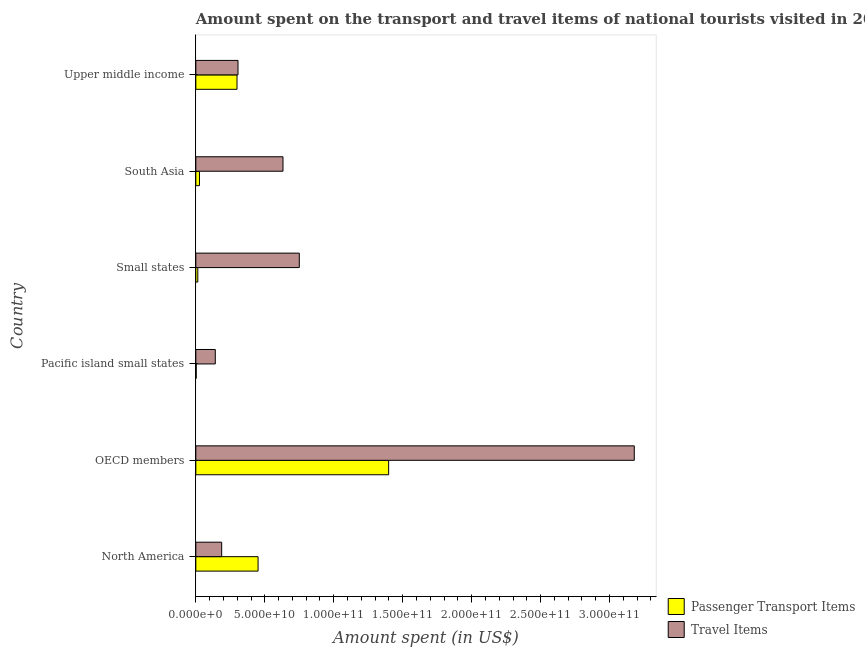How many groups of bars are there?
Your response must be concise. 6. Are the number of bars per tick equal to the number of legend labels?
Ensure brevity in your answer.  Yes. Are the number of bars on each tick of the Y-axis equal?
Offer a very short reply. Yes. What is the label of the 3rd group of bars from the top?
Provide a succinct answer. Small states. What is the amount spent in travel items in Small states?
Your answer should be very brief. 7.50e+1. Across all countries, what is the maximum amount spent in travel items?
Your response must be concise. 3.18e+11. Across all countries, what is the minimum amount spent in travel items?
Keep it short and to the point. 1.41e+1. In which country was the amount spent on passenger transport items maximum?
Make the answer very short. OECD members. In which country was the amount spent in travel items minimum?
Offer a terse response. Pacific island small states. What is the total amount spent in travel items in the graph?
Provide a short and direct response. 5.20e+11. What is the difference between the amount spent on passenger transport items in North America and that in Small states?
Ensure brevity in your answer.  4.37e+1. What is the difference between the amount spent in travel items in Pacific island small states and the amount spent on passenger transport items in Small states?
Make the answer very short. 1.27e+1. What is the average amount spent on passenger transport items per country?
Your answer should be compact. 3.65e+1. What is the difference between the amount spent on passenger transport items and amount spent in travel items in North America?
Provide a short and direct response. 2.64e+1. In how many countries, is the amount spent in travel items greater than 170000000000 US$?
Your response must be concise. 1. What is the ratio of the amount spent on passenger transport items in Pacific island small states to that in Small states?
Ensure brevity in your answer.  0.21. What is the difference between the highest and the second highest amount spent on passenger transport items?
Your answer should be very brief. 9.47e+1. What is the difference between the highest and the lowest amount spent in travel items?
Make the answer very short. 3.04e+11. In how many countries, is the amount spent on passenger transport items greater than the average amount spent on passenger transport items taken over all countries?
Offer a very short reply. 2. Is the sum of the amount spent on passenger transport items in Small states and Upper middle income greater than the maximum amount spent in travel items across all countries?
Your response must be concise. No. What does the 1st bar from the top in OECD members represents?
Keep it short and to the point. Travel Items. What does the 1st bar from the bottom in North America represents?
Your response must be concise. Passenger Transport Items. Are all the bars in the graph horizontal?
Keep it short and to the point. Yes. What is the difference between two consecutive major ticks on the X-axis?
Provide a succinct answer. 5.00e+1. Are the values on the major ticks of X-axis written in scientific E-notation?
Keep it short and to the point. Yes. Does the graph contain grids?
Give a very brief answer. No. Where does the legend appear in the graph?
Your answer should be very brief. Bottom right. What is the title of the graph?
Offer a very short reply. Amount spent on the transport and travel items of national tourists visited in 2013. Does "Public funds" appear as one of the legend labels in the graph?
Your answer should be compact. No. What is the label or title of the X-axis?
Your answer should be compact. Amount spent (in US$). What is the label or title of the Y-axis?
Your answer should be very brief. Country. What is the Amount spent (in US$) in Passenger Transport Items in North America?
Make the answer very short. 4.51e+1. What is the Amount spent (in US$) in Travel Items in North America?
Ensure brevity in your answer.  1.87e+1. What is the Amount spent (in US$) of Passenger Transport Items in OECD members?
Your answer should be very brief. 1.40e+11. What is the Amount spent (in US$) in Travel Items in OECD members?
Keep it short and to the point. 3.18e+11. What is the Amount spent (in US$) of Passenger Transport Items in Pacific island small states?
Your answer should be compact. 2.99e+08. What is the Amount spent (in US$) in Travel Items in Pacific island small states?
Offer a terse response. 1.41e+1. What is the Amount spent (in US$) in Passenger Transport Items in Small states?
Give a very brief answer. 1.43e+09. What is the Amount spent (in US$) of Travel Items in Small states?
Make the answer very short. 7.50e+1. What is the Amount spent (in US$) of Passenger Transport Items in South Asia?
Give a very brief answer. 2.64e+09. What is the Amount spent (in US$) in Travel Items in South Asia?
Your answer should be compact. 6.32e+1. What is the Amount spent (in US$) in Passenger Transport Items in Upper middle income?
Ensure brevity in your answer.  2.99e+1. What is the Amount spent (in US$) in Travel Items in Upper middle income?
Offer a very short reply. 3.06e+1. Across all countries, what is the maximum Amount spent (in US$) in Passenger Transport Items?
Your answer should be very brief. 1.40e+11. Across all countries, what is the maximum Amount spent (in US$) of Travel Items?
Keep it short and to the point. 3.18e+11. Across all countries, what is the minimum Amount spent (in US$) in Passenger Transport Items?
Offer a very short reply. 2.99e+08. Across all countries, what is the minimum Amount spent (in US$) of Travel Items?
Your response must be concise. 1.41e+1. What is the total Amount spent (in US$) in Passenger Transport Items in the graph?
Ensure brevity in your answer.  2.19e+11. What is the total Amount spent (in US$) in Travel Items in the graph?
Your answer should be compact. 5.20e+11. What is the difference between the Amount spent (in US$) of Passenger Transport Items in North America and that in OECD members?
Your answer should be compact. -9.47e+1. What is the difference between the Amount spent (in US$) of Travel Items in North America and that in OECD members?
Provide a succinct answer. -2.99e+11. What is the difference between the Amount spent (in US$) of Passenger Transport Items in North America and that in Pacific island small states?
Provide a short and direct response. 4.48e+1. What is the difference between the Amount spent (in US$) of Travel Items in North America and that in Pacific island small states?
Your response must be concise. 4.63e+09. What is the difference between the Amount spent (in US$) in Passenger Transport Items in North America and that in Small states?
Your answer should be very brief. 4.37e+1. What is the difference between the Amount spent (in US$) in Travel Items in North America and that in Small states?
Ensure brevity in your answer.  -5.63e+1. What is the difference between the Amount spent (in US$) in Passenger Transport Items in North America and that in South Asia?
Your answer should be compact. 4.25e+1. What is the difference between the Amount spent (in US$) in Travel Items in North America and that in South Asia?
Provide a succinct answer. -4.45e+1. What is the difference between the Amount spent (in US$) of Passenger Transport Items in North America and that in Upper middle income?
Your answer should be very brief. 1.53e+1. What is the difference between the Amount spent (in US$) in Travel Items in North America and that in Upper middle income?
Provide a succinct answer. -1.18e+1. What is the difference between the Amount spent (in US$) in Passenger Transport Items in OECD members and that in Pacific island small states?
Your response must be concise. 1.40e+11. What is the difference between the Amount spent (in US$) in Travel Items in OECD members and that in Pacific island small states?
Your response must be concise. 3.04e+11. What is the difference between the Amount spent (in US$) in Passenger Transport Items in OECD members and that in Small states?
Provide a succinct answer. 1.38e+11. What is the difference between the Amount spent (in US$) in Travel Items in OECD members and that in Small states?
Offer a very short reply. 2.43e+11. What is the difference between the Amount spent (in US$) in Passenger Transport Items in OECD members and that in South Asia?
Provide a succinct answer. 1.37e+11. What is the difference between the Amount spent (in US$) of Travel Items in OECD members and that in South Asia?
Your answer should be very brief. 2.55e+11. What is the difference between the Amount spent (in US$) of Passenger Transport Items in OECD members and that in Upper middle income?
Ensure brevity in your answer.  1.10e+11. What is the difference between the Amount spent (in US$) of Travel Items in OECD members and that in Upper middle income?
Provide a succinct answer. 2.87e+11. What is the difference between the Amount spent (in US$) of Passenger Transport Items in Pacific island small states and that in Small states?
Provide a short and direct response. -1.13e+09. What is the difference between the Amount spent (in US$) in Travel Items in Pacific island small states and that in Small states?
Provide a succinct answer. -6.09e+1. What is the difference between the Amount spent (in US$) in Passenger Transport Items in Pacific island small states and that in South Asia?
Your answer should be very brief. -2.34e+09. What is the difference between the Amount spent (in US$) of Travel Items in Pacific island small states and that in South Asia?
Provide a short and direct response. -4.91e+1. What is the difference between the Amount spent (in US$) of Passenger Transport Items in Pacific island small states and that in Upper middle income?
Provide a succinct answer. -2.96e+1. What is the difference between the Amount spent (in US$) of Travel Items in Pacific island small states and that in Upper middle income?
Keep it short and to the point. -1.65e+1. What is the difference between the Amount spent (in US$) of Passenger Transport Items in Small states and that in South Asia?
Provide a succinct answer. -1.21e+09. What is the difference between the Amount spent (in US$) of Travel Items in Small states and that in South Asia?
Your response must be concise. 1.18e+1. What is the difference between the Amount spent (in US$) of Passenger Transport Items in Small states and that in Upper middle income?
Your response must be concise. -2.84e+1. What is the difference between the Amount spent (in US$) in Travel Items in Small states and that in Upper middle income?
Offer a very short reply. 4.44e+1. What is the difference between the Amount spent (in US$) of Passenger Transport Items in South Asia and that in Upper middle income?
Make the answer very short. -2.72e+1. What is the difference between the Amount spent (in US$) of Travel Items in South Asia and that in Upper middle income?
Make the answer very short. 3.26e+1. What is the difference between the Amount spent (in US$) of Passenger Transport Items in North America and the Amount spent (in US$) of Travel Items in OECD members?
Make the answer very short. -2.73e+11. What is the difference between the Amount spent (in US$) of Passenger Transport Items in North America and the Amount spent (in US$) of Travel Items in Pacific island small states?
Make the answer very short. 3.10e+1. What is the difference between the Amount spent (in US$) of Passenger Transport Items in North America and the Amount spent (in US$) of Travel Items in Small states?
Your answer should be very brief. -2.99e+1. What is the difference between the Amount spent (in US$) of Passenger Transport Items in North America and the Amount spent (in US$) of Travel Items in South Asia?
Your answer should be compact. -1.81e+1. What is the difference between the Amount spent (in US$) of Passenger Transport Items in North America and the Amount spent (in US$) of Travel Items in Upper middle income?
Ensure brevity in your answer.  1.45e+1. What is the difference between the Amount spent (in US$) in Passenger Transport Items in OECD members and the Amount spent (in US$) in Travel Items in Pacific island small states?
Give a very brief answer. 1.26e+11. What is the difference between the Amount spent (in US$) in Passenger Transport Items in OECD members and the Amount spent (in US$) in Travel Items in Small states?
Keep it short and to the point. 6.48e+1. What is the difference between the Amount spent (in US$) in Passenger Transport Items in OECD members and the Amount spent (in US$) in Travel Items in South Asia?
Provide a succinct answer. 7.66e+1. What is the difference between the Amount spent (in US$) of Passenger Transport Items in OECD members and the Amount spent (in US$) of Travel Items in Upper middle income?
Keep it short and to the point. 1.09e+11. What is the difference between the Amount spent (in US$) in Passenger Transport Items in Pacific island small states and the Amount spent (in US$) in Travel Items in Small states?
Keep it short and to the point. -7.47e+1. What is the difference between the Amount spent (in US$) in Passenger Transport Items in Pacific island small states and the Amount spent (in US$) in Travel Items in South Asia?
Provide a short and direct response. -6.29e+1. What is the difference between the Amount spent (in US$) of Passenger Transport Items in Pacific island small states and the Amount spent (in US$) of Travel Items in Upper middle income?
Your response must be concise. -3.03e+1. What is the difference between the Amount spent (in US$) of Passenger Transport Items in Small states and the Amount spent (in US$) of Travel Items in South Asia?
Provide a short and direct response. -6.18e+1. What is the difference between the Amount spent (in US$) in Passenger Transport Items in Small states and the Amount spent (in US$) in Travel Items in Upper middle income?
Your response must be concise. -2.92e+1. What is the difference between the Amount spent (in US$) of Passenger Transport Items in South Asia and the Amount spent (in US$) of Travel Items in Upper middle income?
Give a very brief answer. -2.79e+1. What is the average Amount spent (in US$) of Passenger Transport Items per country?
Make the answer very short. 3.65e+1. What is the average Amount spent (in US$) in Travel Items per country?
Offer a terse response. 8.66e+1. What is the difference between the Amount spent (in US$) of Passenger Transport Items and Amount spent (in US$) of Travel Items in North America?
Provide a short and direct response. 2.64e+1. What is the difference between the Amount spent (in US$) in Passenger Transport Items and Amount spent (in US$) in Travel Items in OECD members?
Provide a succinct answer. -1.78e+11. What is the difference between the Amount spent (in US$) in Passenger Transport Items and Amount spent (in US$) in Travel Items in Pacific island small states?
Provide a succinct answer. -1.38e+1. What is the difference between the Amount spent (in US$) of Passenger Transport Items and Amount spent (in US$) of Travel Items in Small states?
Keep it short and to the point. -7.36e+1. What is the difference between the Amount spent (in US$) of Passenger Transport Items and Amount spent (in US$) of Travel Items in South Asia?
Your answer should be compact. -6.06e+1. What is the difference between the Amount spent (in US$) in Passenger Transport Items and Amount spent (in US$) in Travel Items in Upper middle income?
Give a very brief answer. -7.19e+08. What is the ratio of the Amount spent (in US$) in Passenger Transport Items in North America to that in OECD members?
Offer a very short reply. 0.32. What is the ratio of the Amount spent (in US$) in Travel Items in North America to that in OECD members?
Your answer should be very brief. 0.06. What is the ratio of the Amount spent (in US$) of Passenger Transport Items in North America to that in Pacific island small states?
Make the answer very short. 151.12. What is the ratio of the Amount spent (in US$) in Travel Items in North America to that in Pacific island small states?
Offer a terse response. 1.33. What is the ratio of the Amount spent (in US$) in Passenger Transport Items in North America to that in Small states?
Keep it short and to the point. 31.48. What is the ratio of the Amount spent (in US$) of Travel Items in North America to that in Small states?
Provide a succinct answer. 0.25. What is the ratio of the Amount spent (in US$) of Passenger Transport Items in North America to that in South Asia?
Give a very brief answer. 17.09. What is the ratio of the Amount spent (in US$) of Travel Items in North America to that in South Asia?
Provide a succinct answer. 0.3. What is the ratio of the Amount spent (in US$) of Passenger Transport Items in North America to that in Upper middle income?
Make the answer very short. 1.51. What is the ratio of the Amount spent (in US$) of Travel Items in North America to that in Upper middle income?
Your answer should be compact. 0.61. What is the ratio of the Amount spent (in US$) of Passenger Transport Items in OECD members to that in Pacific island small states?
Your response must be concise. 468.21. What is the ratio of the Amount spent (in US$) of Travel Items in OECD members to that in Pacific island small states?
Keep it short and to the point. 22.53. What is the ratio of the Amount spent (in US$) of Passenger Transport Items in OECD members to that in Small states?
Make the answer very short. 97.53. What is the ratio of the Amount spent (in US$) of Travel Items in OECD members to that in Small states?
Provide a short and direct response. 4.24. What is the ratio of the Amount spent (in US$) in Passenger Transport Items in OECD members to that in South Asia?
Your answer should be very brief. 52.95. What is the ratio of the Amount spent (in US$) of Travel Items in OECD members to that in South Asia?
Provide a succinct answer. 5.03. What is the ratio of the Amount spent (in US$) of Passenger Transport Items in OECD members to that in Upper middle income?
Give a very brief answer. 4.68. What is the ratio of the Amount spent (in US$) in Travel Items in OECD members to that in Upper middle income?
Your answer should be compact. 10.4. What is the ratio of the Amount spent (in US$) in Passenger Transport Items in Pacific island small states to that in Small states?
Your answer should be very brief. 0.21. What is the ratio of the Amount spent (in US$) in Travel Items in Pacific island small states to that in Small states?
Your answer should be very brief. 0.19. What is the ratio of the Amount spent (in US$) in Passenger Transport Items in Pacific island small states to that in South Asia?
Make the answer very short. 0.11. What is the ratio of the Amount spent (in US$) of Travel Items in Pacific island small states to that in South Asia?
Offer a very short reply. 0.22. What is the ratio of the Amount spent (in US$) of Passenger Transport Items in Pacific island small states to that in Upper middle income?
Your answer should be compact. 0.01. What is the ratio of the Amount spent (in US$) in Travel Items in Pacific island small states to that in Upper middle income?
Give a very brief answer. 0.46. What is the ratio of the Amount spent (in US$) in Passenger Transport Items in Small states to that in South Asia?
Offer a terse response. 0.54. What is the ratio of the Amount spent (in US$) of Travel Items in Small states to that in South Asia?
Make the answer very short. 1.19. What is the ratio of the Amount spent (in US$) in Passenger Transport Items in Small states to that in Upper middle income?
Offer a very short reply. 0.05. What is the ratio of the Amount spent (in US$) of Travel Items in Small states to that in Upper middle income?
Your answer should be compact. 2.45. What is the ratio of the Amount spent (in US$) of Passenger Transport Items in South Asia to that in Upper middle income?
Offer a very short reply. 0.09. What is the ratio of the Amount spent (in US$) in Travel Items in South Asia to that in Upper middle income?
Keep it short and to the point. 2.07. What is the difference between the highest and the second highest Amount spent (in US$) in Passenger Transport Items?
Your answer should be very brief. 9.47e+1. What is the difference between the highest and the second highest Amount spent (in US$) in Travel Items?
Provide a short and direct response. 2.43e+11. What is the difference between the highest and the lowest Amount spent (in US$) in Passenger Transport Items?
Make the answer very short. 1.40e+11. What is the difference between the highest and the lowest Amount spent (in US$) of Travel Items?
Your answer should be compact. 3.04e+11. 